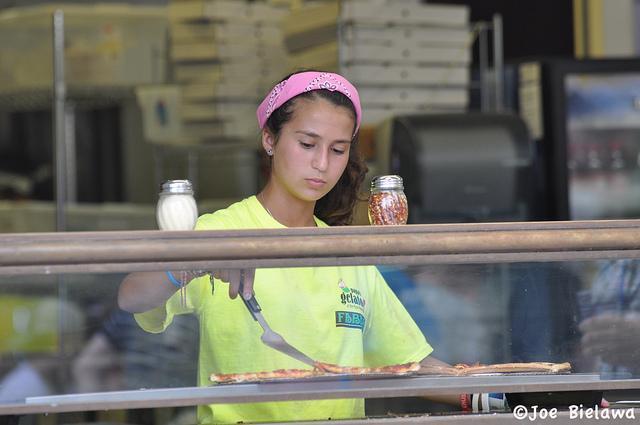How many hooves does the cow on the right have?
Give a very brief answer. 0. 